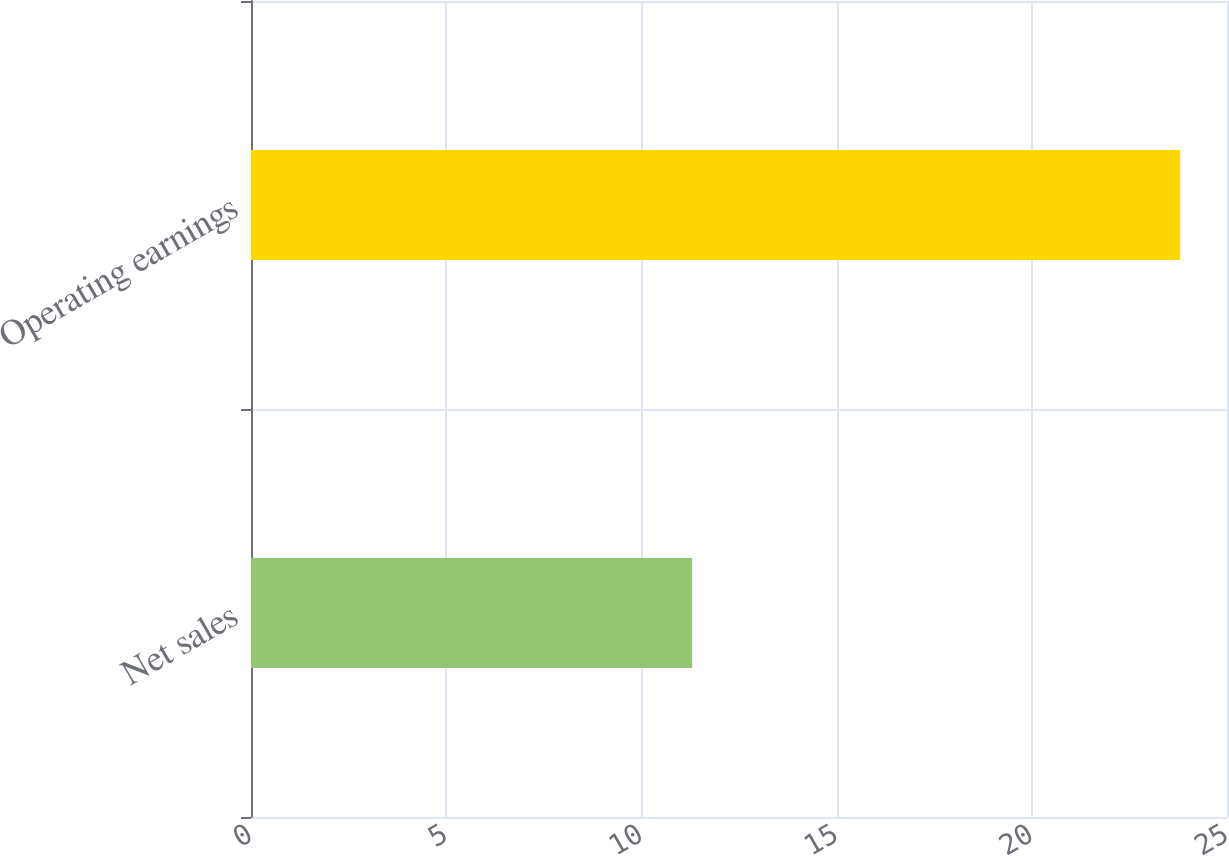Convert chart. <chart><loc_0><loc_0><loc_500><loc_500><bar_chart><fcel>Net sales<fcel>Operating earnings<nl><fcel>11.3<fcel>23.8<nl></chart> 